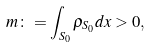<formula> <loc_0><loc_0><loc_500><loc_500>m \colon = \int _ { S _ { 0 } } \rho _ { S _ { 0 } } d x > 0 ,</formula> 